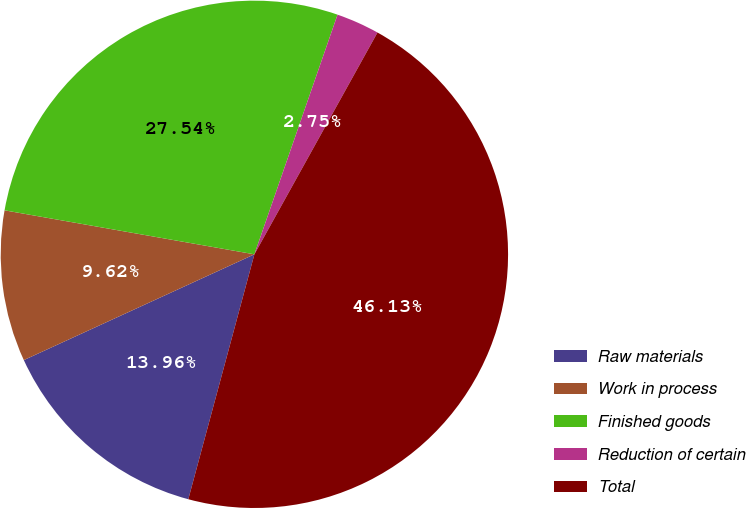Convert chart to OTSL. <chart><loc_0><loc_0><loc_500><loc_500><pie_chart><fcel>Raw materials<fcel>Work in process<fcel>Finished goods<fcel>Reduction of certain<fcel>Total<nl><fcel>13.96%<fcel>9.62%<fcel>27.54%<fcel>2.75%<fcel>46.13%<nl></chart> 